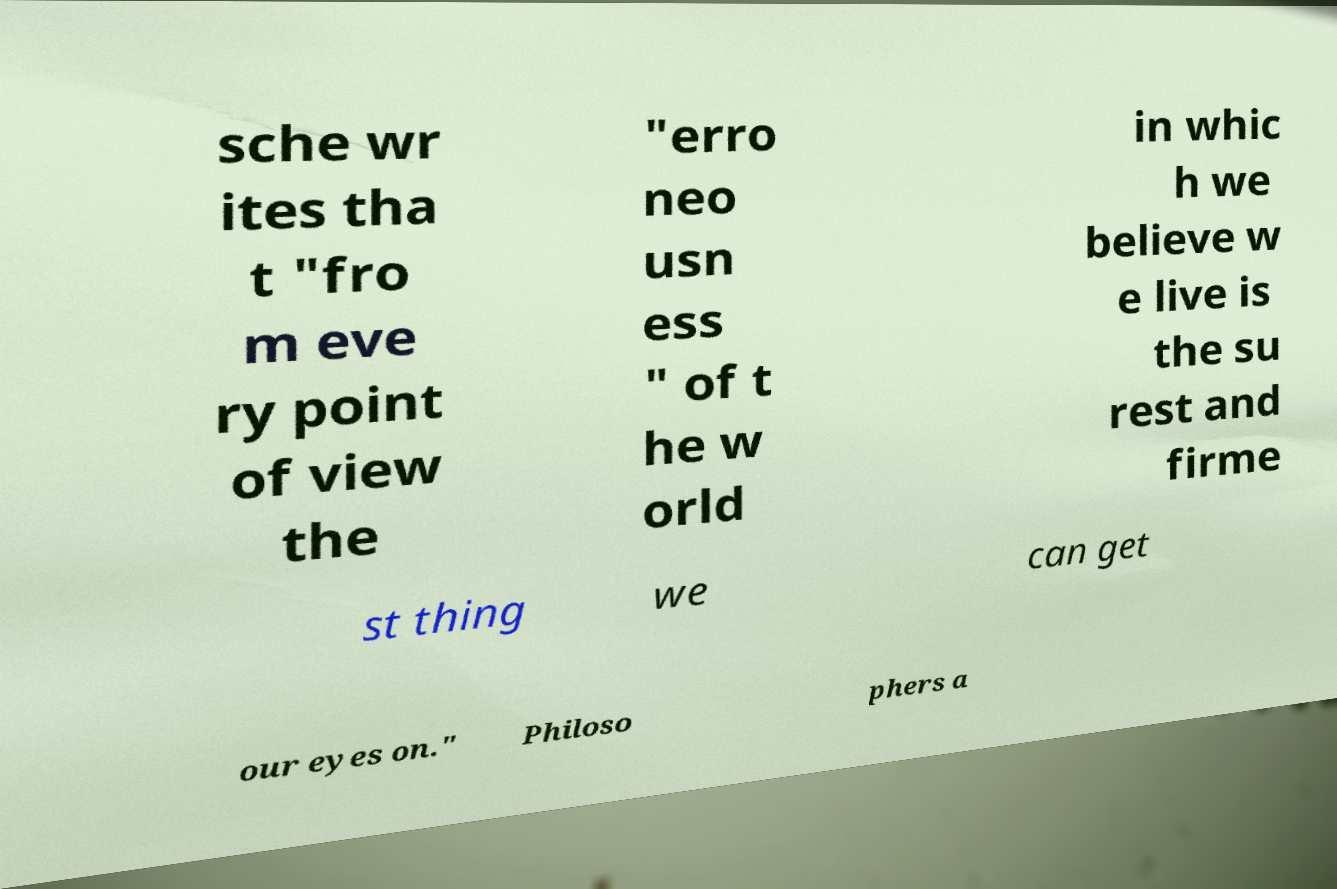I need the written content from this picture converted into text. Can you do that? sche wr ites tha t "fro m eve ry point of view the "erro neo usn ess " of t he w orld in whic h we believe w e live is the su rest and firme st thing we can get our eyes on." Philoso phers a 